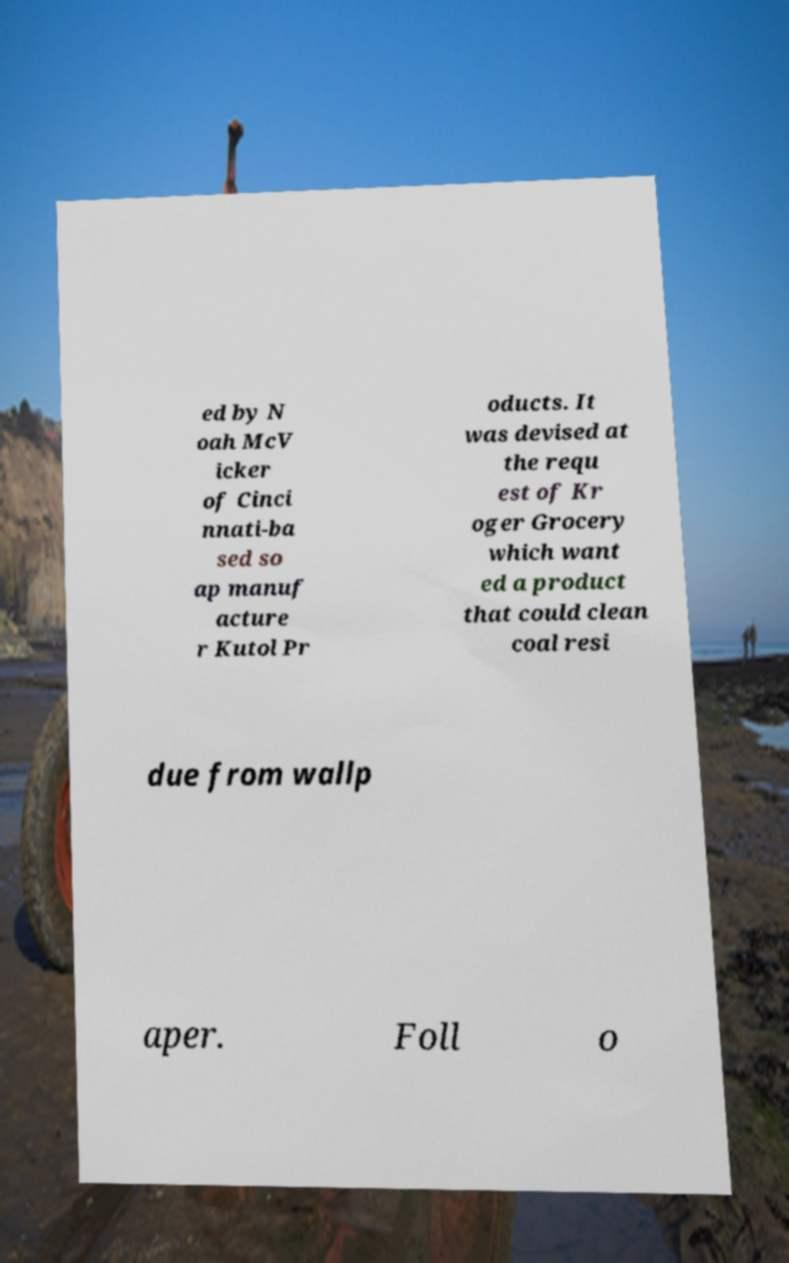There's text embedded in this image that I need extracted. Can you transcribe it verbatim? ed by N oah McV icker of Cinci nnati-ba sed so ap manuf acture r Kutol Pr oducts. It was devised at the requ est of Kr oger Grocery which want ed a product that could clean coal resi due from wallp aper. Foll o 